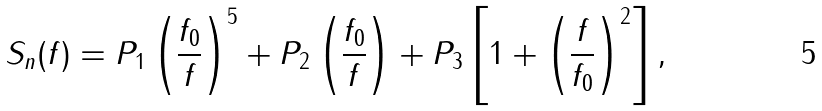<formula> <loc_0><loc_0><loc_500><loc_500>S _ { n } ( f ) = P _ { 1 } \left ( \frac { f _ { 0 } } { f } \right ) ^ { 5 } + P _ { 2 } \left ( \frac { f _ { 0 } } { f } \right ) + P _ { 3 } \left [ 1 + \left ( \frac { f } { f _ { 0 } } \right ) ^ { 2 } \right ] ,</formula> 